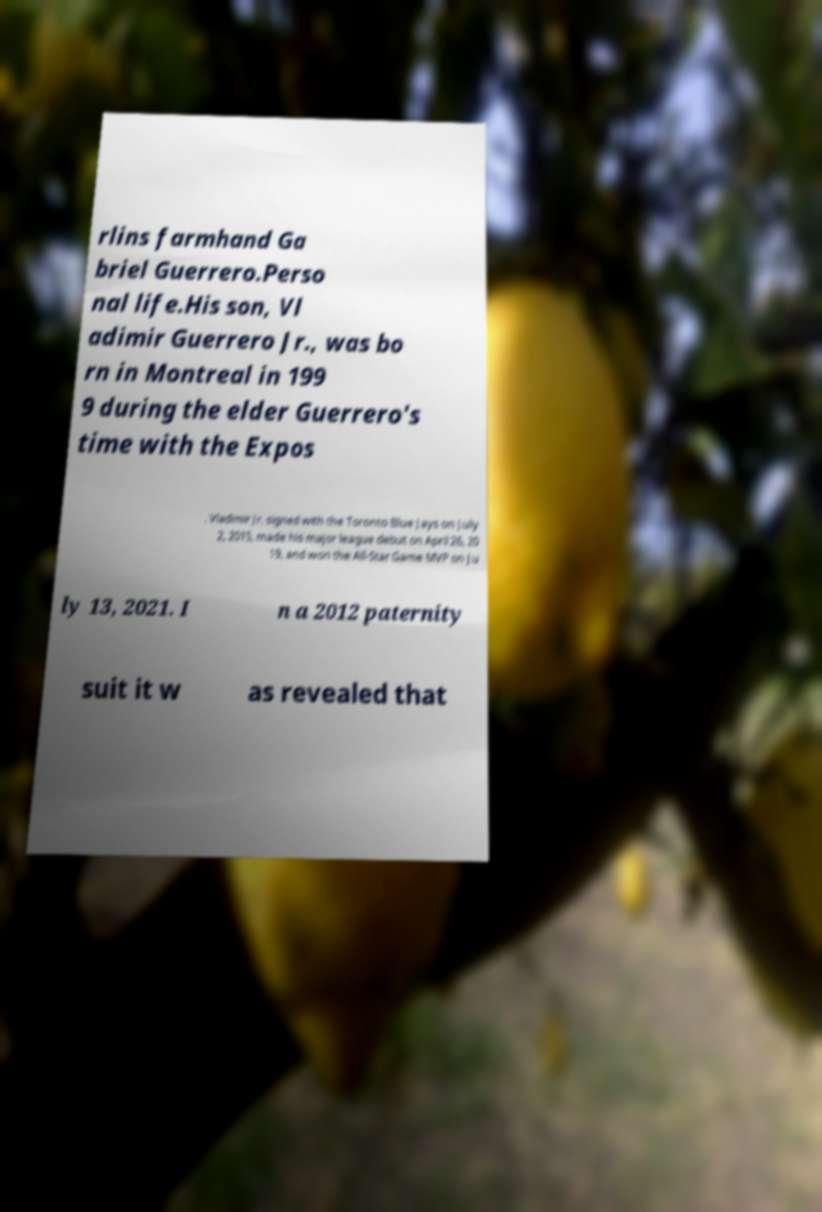Could you extract and type out the text from this image? rlins farmhand Ga briel Guerrero.Perso nal life.His son, Vl adimir Guerrero Jr., was bo rn in Montreal in 199 9 during the elder Guerrero's time with the Expos . Vladimir Jr. signed with the Toronto Blue Jays on July 2, 2015, made his major league debut on April 26, 20 19, and won the All-Star Game MVP on Ju ly 13, 2021. I n a 2012 paternity suit it w as revealed that 